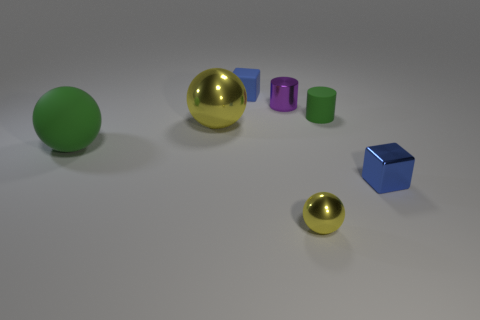What material is the blue cube in front of the tiny cylinder that is behind the tiny cylinder on the right side of the tiny purple cylinder made of? The blue cube, positioned in front of the small cylinder and to the right of the tiny purple cylinder, appears to be made of a plastic material with a matte finish, characterized by its solid color and lack of reflective properties common to metals. 